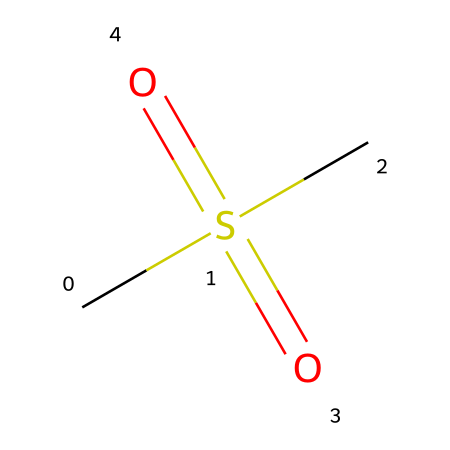What is the molecular formula of the compound represented by the SMILES? The SMILES notation indicates the presence of carbon (C) and sulfur (S) atoms, along with oxygen (O). By analyzing the structure, we can derive the molecular formula which is composed of one carbon atom, two sulfur atoms, and four oxygen atoms.
Answer: C1S2O4 How many distinct elements are found in this chemical structure? By inspecting the SMILES, we can identify three different elements: carbon (C), sulfur (S), and oxygen (O). Each of these elements is represented in the chemical structure.
Answer: three What type of functional group is present in this compound? The compound shows a sulfonic acid functional group, characterized by the presence of sulfur (S) bonded to double bonded oxygen and hydroxy (–OH) groups. The structure CS(S)(=O)=O clearly fits this description with S=O and an –OH bond.
Answer: sulfonic acid How many bonds are present in the molecular structure? Counting the bonds involves assessing the connectivity within the SMILES notation: there are single bonds and double bonds evident in the structure. It is necessary to tally each connection. In total, there are six bonds reflected in the represented compound.
Answer: six What functional component contributes to the compound's potential flexibility? The sulfonic acid group can interact with water and other molecules, allowing for potential flexibility in biological systems, contributing to its activity in joint supplements. This interaction helps in maintaining the structure's dynamic nature.
Answer: sulfonic acid What is the main application of this type of chemical compound? Chemicals similar to this one, especially those with sulfonic acid groups, are often used in joint supplements to enhance flexibility and reduce pain through their interactions with body tissues. They help in the maintenance of joint health.
Answer: joint supplements 